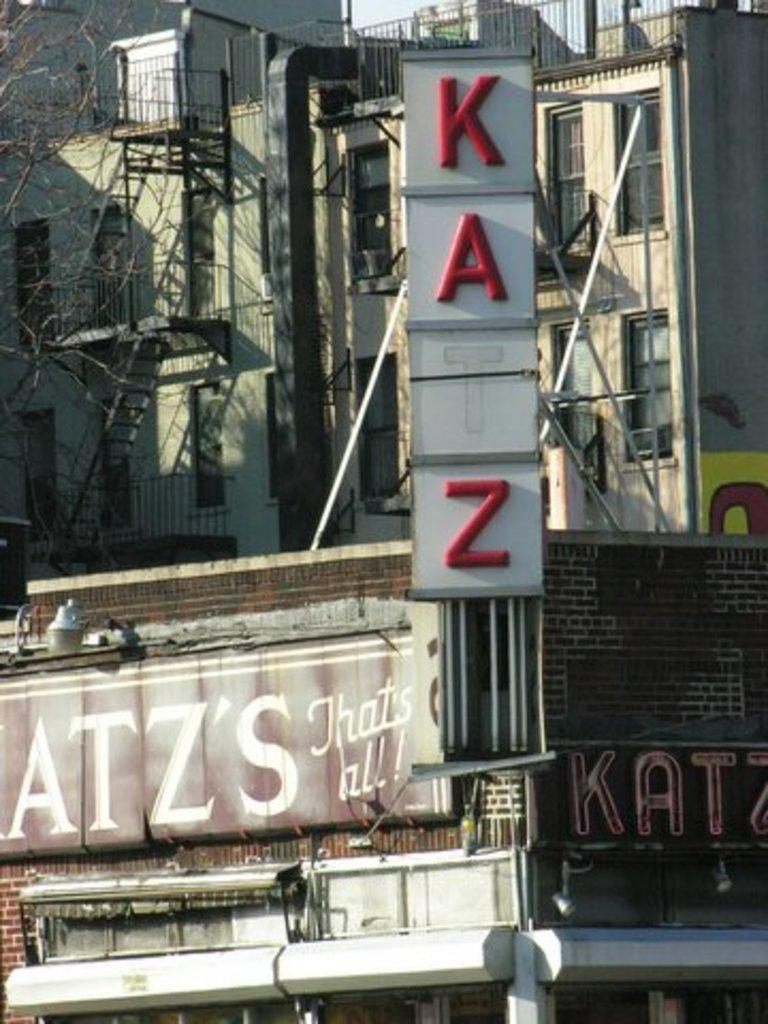What type of structures can be seen in the image? There are buildings in the image. What other objects are visible in the image? There are hoardings and metal rods present in the image. Where is the tree located in the image? The tree is on the left side of the image. What type of flesh can be seen on the buildings in the image? There is no flesh present on the buildings in the image; they are made of inanimate materials such as concrete or brick. 